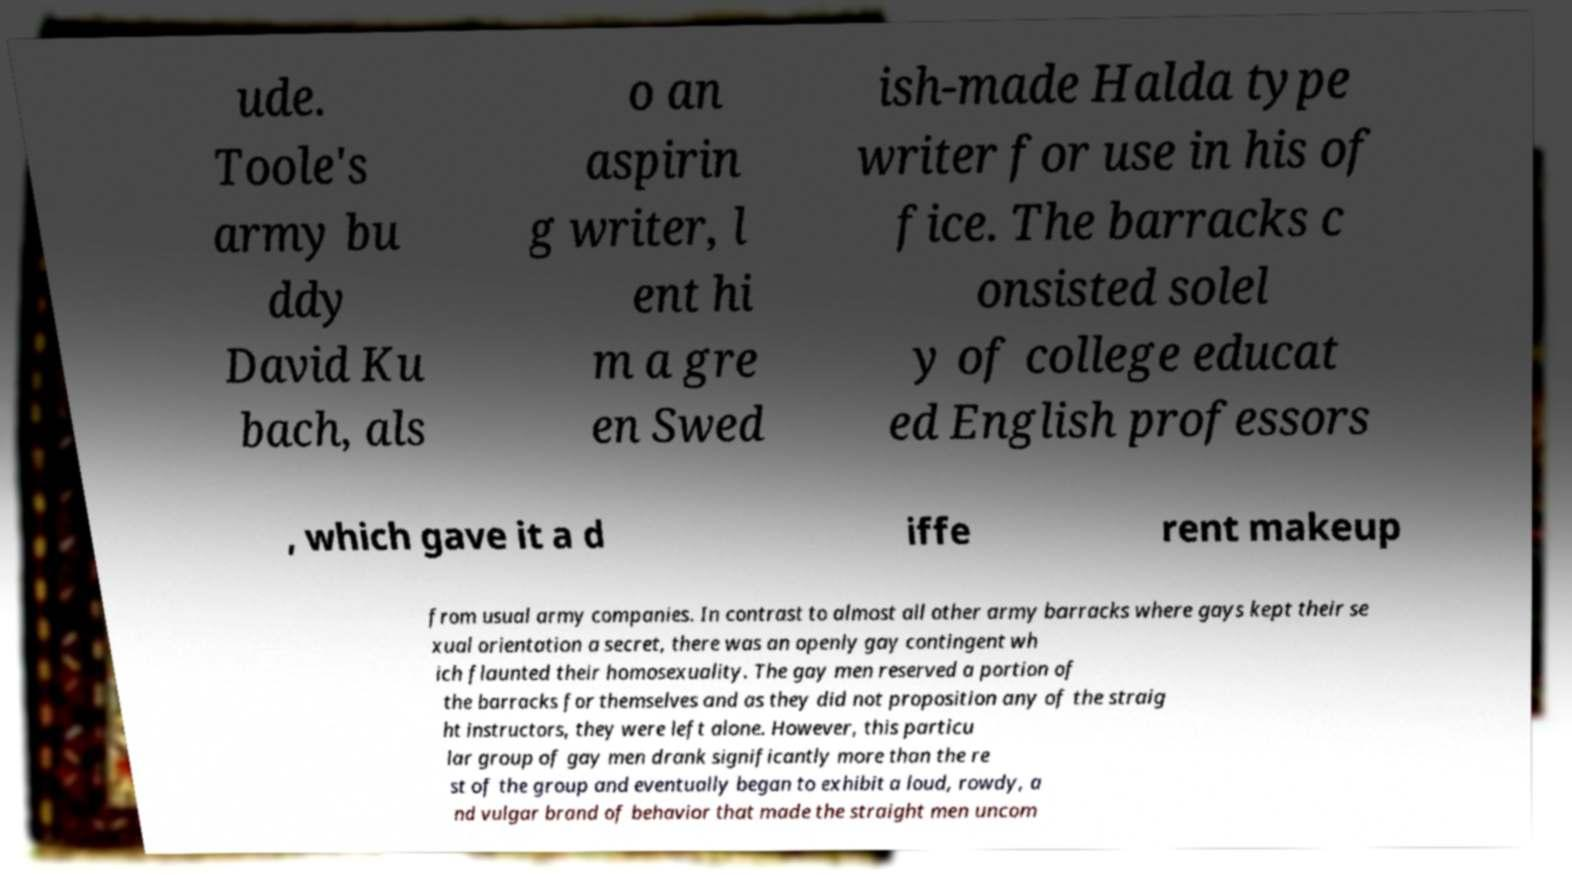Can you accurately transcribe the text from the provided image for me? ude. Toole's army bu ddy David Ku bach, als o an aspirin g writer, l ent hi m a gre en Swed ish-made Halda type writer for use in his of fice. The barracks c onsisted solel y of college educat ed English professors , which gave it a d iffe rent makeup from usual army companies. In contrast to almost all other army barracks where gays kept their se xual orientation a secret, there was an openly gay contingent wh ich flaunted their homosexuality. The gay men reserved a portion of the barracks for themselves and as they did not proposition any of the straig ht instructors, they were left alone. However, this particu lar group of gay men drank significantly more than the re st of the group and eventually began to exhibit a loud, rowdy, a nd vulgar brand of behavior that made the straight men uncom 